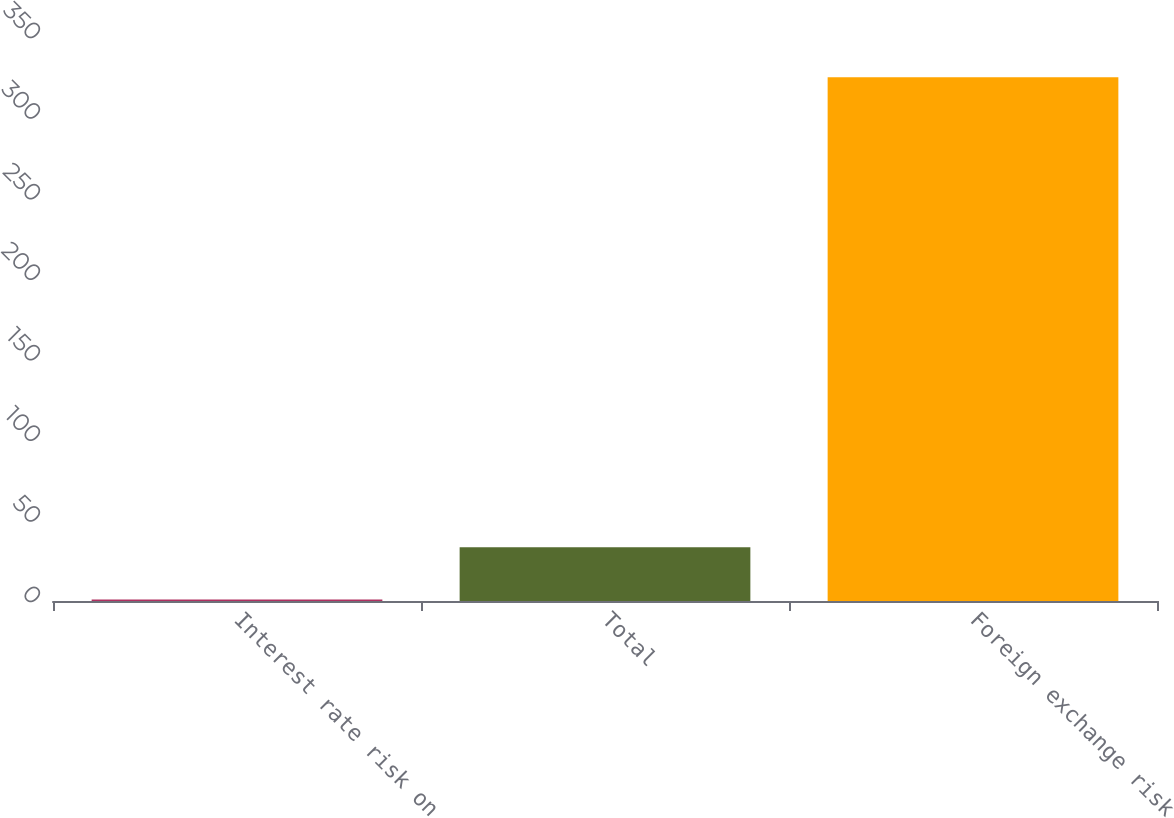<chart> <loc_0><loc_0><loc_500><loc_500><bar_chart><fcel>Interest rate risk on<fcel>Total<fcel>Foreign exchange risk<nl><fcel>1<fcel>33.4<fcel>325<nl></chart> 